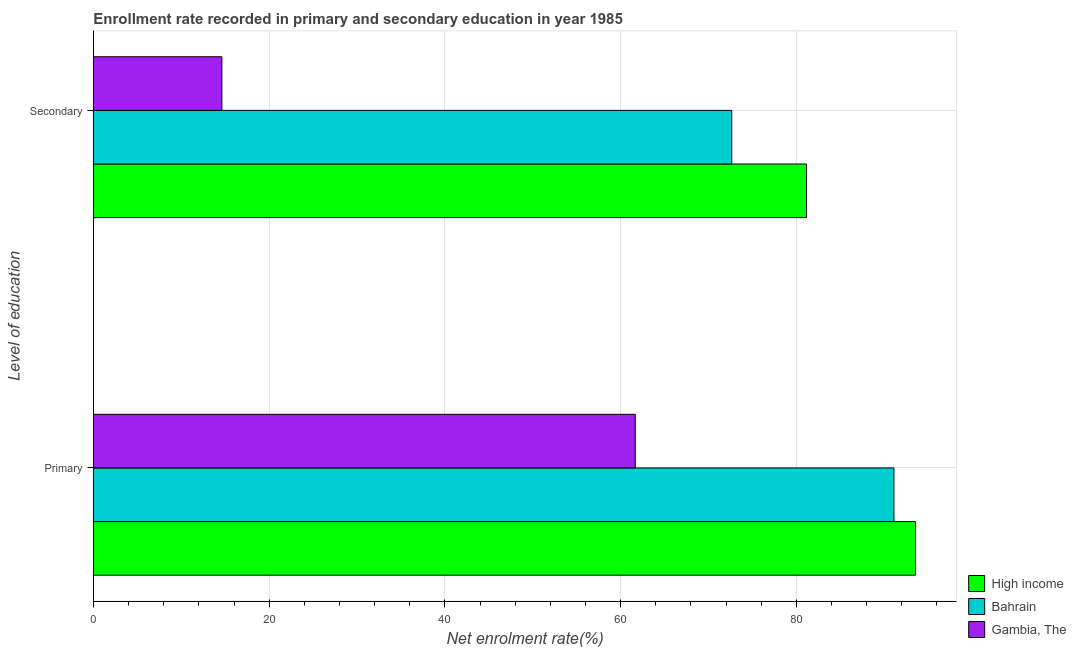Are the number of bars per tick equal to the number of legend labels?
Your answer should be compact. Yes. How many bars are there on the 2nd tick from the top?
Make the answer very short. 3. What is the label of the 2nd group of bars from the top?
Give a very brief answer. Primary. What is the enrollment rate in secondary education in Gambia, The?
Your answer should be very brief. 14.62. Across all countries, what is the maximum enrollment rate in primary education?
Your answer should be very brief. 93.57. Across all countries, what is the minimum enrollment rate in secondary education?
Provide a succinct answer. 14.62. In which country was the enrollment rate in secondary education maximum?
Your answer should be compact. High income. In which country was the enrollment rate in primary education minimum?
Keep it short and to the point. Gambia, The. What is the total enrollment rate in primary education in the graph?
Your answer should be compact. 246.36. What is the difference between the enrollment rate in secondary education in High income and that in Gambia, The?
Your answer should be compact. 66.55. What is the difference between the enrollment rate in primary education in High income and the enrollment rate in secondary education in Gambia, The?
Provide a succinct answer. 78.96. What is the average enrollment rate in secondary education per country?
Provide a short and direct response. 56.14. What is the difference between the enrollment rate in primary education and enrollment rate in secondary education in High income?
Offer a terse response. 12.41. What is the ratio of the enrollment rate in primary education in High income to that in Bahrain?
Keep it short and to the point. 1.03. Is the enrollment rate in primary education in Bahrain less than that in High income?
Make the answer very short. Yes. In how many countries, is the enrollment rate in secondary education greater than the average enrollment rate in secondary education taken over all countries?
Offer a terse response. 2. What does the 1st bar from the top in Secondary represents?
Ensure brevity in your answer.  Gambia, The. What does the 2nd bar from the bottom in Secondary represents?
Offer a very short reply. Bahrain. Are all the bars in the graph horizontal?
Offer a very short reply. Yes. Are the values on the major ticks of X-axis written in scientific E-notation?
Provide a short and direct response. No. Does the graph contain any zero values?
Give a very brief answer. No. Where does the legend appear in the graph?
Make the answer very short. Bottom right. How many legend labels are there?
Your answer should be compact. 3. What is the title of the graph?
Your answer should be compact. Enrollment rate recorded in primary and secondary education in year 1985. What is the label or title of the X-axis?
Your answer should be compact. Net enrolment rate(%). What is the label or title of the Y-axis?
Offer a terse response. Level of education. What is the Net enrolment rate(%) of High income in Primary?
Make the answer very short. 93.57. What is the Net enrolment rate(%) in Bahrain in Primary?
Your answer should be very brief. 91.12. What is the Net enrolment rate(%) in Gambia, The in Primary?
Keep it short and to the point. 61.67. What is the Net enrolment rate(%) in High income in Secondary?
Provide a succinct answer. 81.17. What is the Net enrolment rate(%) in Bahrain in Secondary?
Make the answer very short. 72.65. What is the Net enrolment rate(%) in Gambia, The in Secondary?
Your answer should be compact. 14.62. Across all Level of education, what is the maximum Net enrolment rate(%) of High income?
Your response must be concise. 93.57. Across all Level of education, what is the maximum Net enrolment rate(%) of Bahrain?
Offer a terse response. 91.12. Across all Level of education, what is the maximum Net enrolment rate(%) in Gambia, The?
Your answer should be compact. 61.67. Across all Level of education, what is the minimum Net enrolment rate(%) in High income?
Ensure brevity in your answer.  81.17. Across all Level of education, what is the minimum Net enrolment rate(%) of Bahrain?
Give a very brief answer. 72.65. Across all Level of education, what is the minimum Net enrolment rate(%) of Gambia, The?
Provide a succinct answer. 14.62. What is the total Net enrolment rate(%) in High income in the graph?
Offer a terse response. 174.74. What is the total Net enrolment rate(%) in Bahrain in the graph?
Your answer should be very brief. 163.77. What is the total Net enrolment rate(%) of Gambia, The in the graph?
Ensure brevity in your answer.  76.29. What is the difference between the Net enrolment rate(%) in High income in Primary and that in Secondary?
Offer a very short reply. 12.41. What is the difference between the Net enrolment rate(%) in Bahrain in Primary and that in Secondary?
Your response must be concise. 18.47. What is the difference between the Net enrolment rate(%) of Gambia, The in Primary and that in Secondary?
Offer a terse response. 47.06. What is the difference between the Net enrolment rate(%) in High income in Primary and the Net enrolment rate(%) in Bahrain in Secondary?
Ensure brevity in your answer.  20.92. What is the difference between the Net enrolment rate(%) in High income in Primary and the Net enrolment rate(%) in Gambia, The in Secondary?
Ensure brevity in your answer.  78.96. What is the difference between the Net enrolment rate(%) in Bahrain in Primary and the Net enrolment rate(%) in Gambia, The in Secondary?
Make the answer very short. 76.5. What is the average Net enrolment rate(%) in High income per Level of education?
Offer a terse response. 87.37. What is the average Net enrolment rate(%) of Bahrain per Level of education?
Provide a short and direct response. 81.88. What is the average Net enrolment rate(%) in Gambia, The per Level of education?
Provide a succinct answer. 38.14. What is the difference between the Net enrolment rate(%) in High income and Net enrolment rate(%) in Bahrain in Primary?
Offer a terse response. 2.46. What is the difference between the Net enrolment rate(%) of High income and Net enrolment rate(%) of Gambia, The in Primary?
Offer a very short reply. 31.9. What is the difference between the Net enrolment rate(%) of Bahrain and Net enrolment rate(%) of Gambia, The in Primary?
Your answer should be compact. 29.45. What is the difference between the Net enrolment rate(%) in High income and Net enrolment rate(%) in Bahrain in Secondary?
Offer a very short reply. 8.52. What is the difference between the Net enrolment rate(%) in High income and Net enrolment rate(%) in Gambia, The in Secondary?
Your answer should be compact. 66.55. What is the difference between the Net enrolment rate(%) in Bahrain and Net enrolment rate(%) in Gambia, The in Secondary?
Provide a succinct answer. 58.04. What is the ratio of the Net enrolment rate(%) of High income in Primary to that in Secondary?
Your response must be concise. 1.15. What is the ratio of the Net enrolment rate(%) in Bahrain in Primary to that in Secondary?
Give a very brief answer. 1.25. What is the ratio of the Net enrolment rate(%) in Gambia, The in Primary to that in Secondary?
Your response must be concise. 4.22. What is the difference between the highest and the second highest Net enrolment rate(%) of High income?
Ensure brevity in your answer.  12.41. What is the difference between the highest and the second highest Net enrolment rate(%) of Bahrain?
Your response must be concise. 18.47. What is the difference between the highest and the second highest Net enrolment rate(%) in Gambia, The?
Ensure brevity in your answer.  47.06. What is the difference between the highest and the lowest Net enrolment rate(%) in High income?
Provide a short and direct response. 12.41. What is the difference between the highest and the lowest Net enrolment rate(%) in Bahrain?
Ensure brevity in your answer.  18.47. What is the difference between the highest and the lowest Net enrolment rate(%) in Gambia, The?
Give a very brief answer. 47.06. 